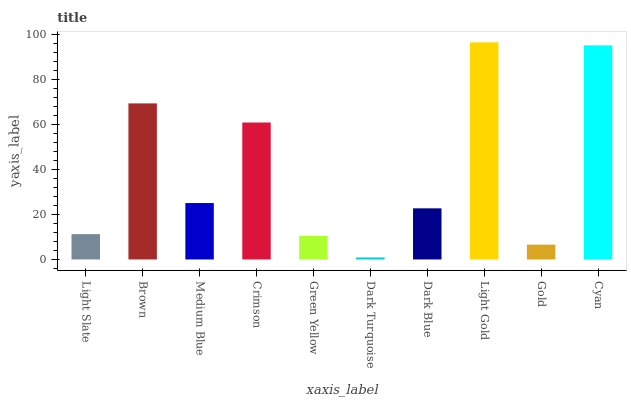Is Brown the minimum?
Answer yes or no. No. Is Brown the maximum?
Answer yes or no. No. Is Brown greater than Light Slate?
Answer yes or no. Yes. Is Light Slate less than Brown?
Answer yes or no. Yes. Is Light Slate greater than Brown?
Answer yes or no. No. Is Brown less than Light Slate?
Answer yes or no. No. Is Medium Blue the high median?
Answer yes or no. Yes. Is Dark Blue the low median?
Answer yes or no. Yes. Is Crimson the high median?
Answer yes or no. No. Is Gold the low median?
Answer yes or no. No. 